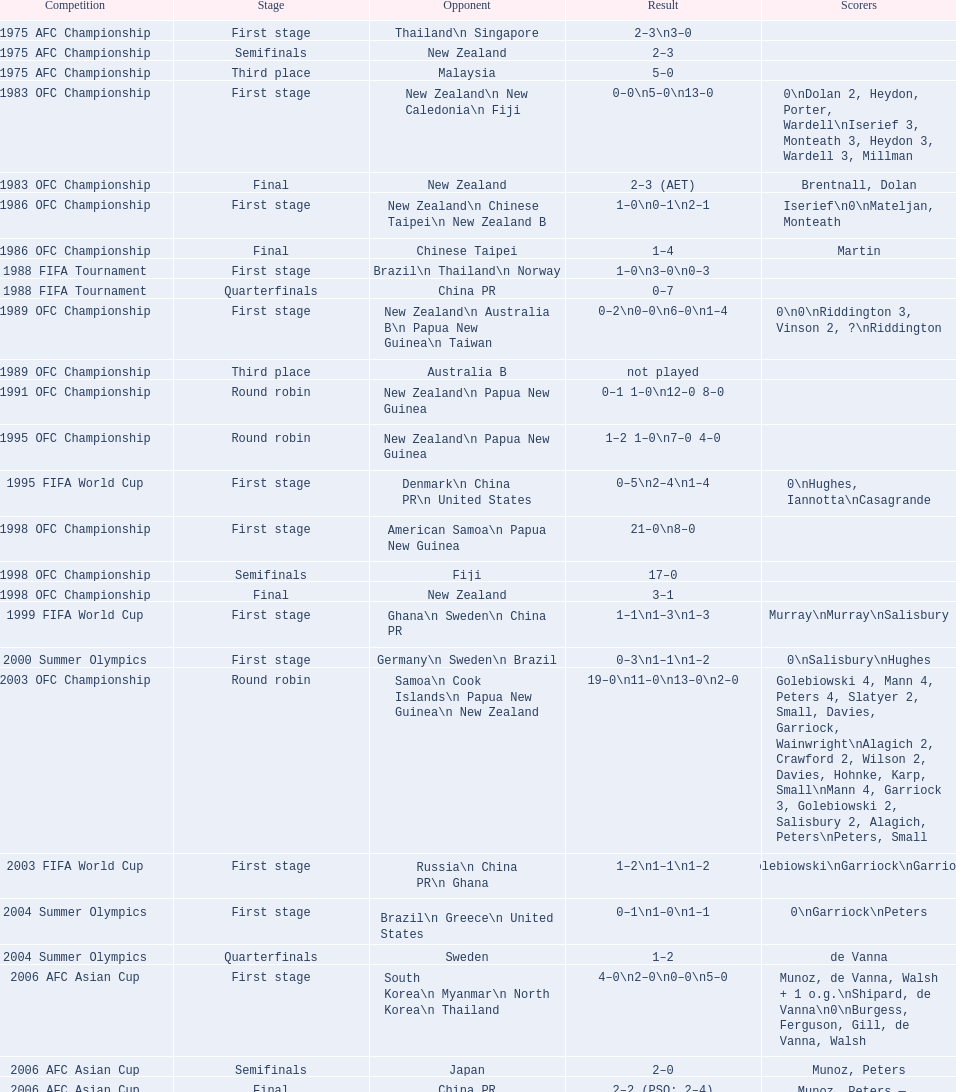Write the full table. {'header': ['Competition', 'Stage', 'Opponent', 'Result', 'Scorers'], 'rows': [['1975 AFC Championship', 'First stage', 'Thailand\\n\xa0Singapore', '2–3\\n3–0', ''], ['1975 AFC Championship', 'Semifinals', 'New Zealand', '2–3', ''], ['1975 AFC Championship', 'Third place', 'Malaysia', '5–0', ''], ['1983 OFC Championship', 'First stage', 'New Zealand\\n\xa0New Caledonia\\n\xa0Fiji', '0–0\\n5–0\\n13–0', '0\\nDolan 2, Heydon, Porter, Wardell\\nIserief 3, Monteath 3, Heydon 3, Wardell 3, Millman'], ['1983 OFC Championship', 'Final', 'New Zealand', '2–3 (AET)', 'Brentnall, Dolan'], ['1986 OFC Championship', 'First stage', 'New Zealand\\n\xa0Chinese Taipei\\n New Zealand B', '1–0\\n0–1\\n2–1', 'Iserief\\n0\\nMateljan, Monteath'], ['1986 OFC Championship', 'Final', 'Chinese Taipei', '1–4', 'Martin'], ['1988 FIFA Tournament', 'First stage', 'Brazil\\n\xa0Thailand\\n\xa0Norway', '1–0\\n3–0\\n0–3', ''], ['1988 FIFA Tournament', 'Quarterfinals', 'China PR', '0–7', ''], ['1989 OFC Championship', 'First stage', 'New Zealand\\n Australia B\\n\xa0Papua New Guinea\\n\xa0Taiwan', '0–2\\n0–0\\n6–0\\n1–4', '0\\n0\\nRiddington 3, Vinson 2,\xa0?\\nRiddington'], ['1989 OFC Championship', 'Third place', 'Australia B', 'not played', ''], ['1991 OFC Championship', 'Round robin', 'New Zealand\\n\xa0Papua New Guinea', '0–1 1–0\\n12–0 8–0', ''], ['1995 OFC Championship', 'Round robin', 'New Zealand\\n\xa0Papua New Guinea', '1–2 1–0\\n7–0 4–0', ''], ['1995 FIFA World Cup', 'First stage', 'Denmark\\n\xa0China PR\\n\xa0United States', '0–5\\n2–4\\n1–4', '0\\nHughes, Iannotta\\nCasagrande'], ['1998 OFC Championship', 'First stage', 'American Samoa\\n\xa0Papua New Guinea', '21–0\\n8–0', ''], ['1998 OFC Championship', 'Semifinals', 'Fiji', '17–0', ''], ['1998 OFC Championship', 'Final', 'New Zealand', '3–1', ''], ['1999 FIFA World Cup', 'First stage', 'Ghana\\n\xa0Sweden\\n\xa0China PR', '1–1\\n1–3\\n1–3', 'Murray\\nMurray\\nSalisbury'], ['2000 Summer Olympics', 'First stage', 'Germany\\n\xa0Sweden\\n\xa0Brazil', '0–3\\n1–1\\n1–2', '0\\nSalisbury\\nHughes'], ['2003 OFC Championship', 'Round robin', 'Samoa\\n\xa0Cook Islands\\n\xa0Papua New Guinea\\n\xa0New Zealand', '19–0\\n11–0\\n13–0\\n2–0', 'Golebiowski 4, Mann 4, Peters 4, Slatyer 2, Small, Davies, Garriock, Wainwright\\nAlagich 2, Crawford 2, Wilson 2, Davies, Hohnke, Karp, Small\\nMann 4, Garriock 3, Golebiowski 2, Salisbury 2, Alagich, Peters\\nPeters, Small'], ['2003 FIFA World Cup', 'First stage', 'Russia\\n\xa0China PR\\n\xa0Ghana', '1–2\\n1–1\\n1–2', 'Golebiowski\\nGarriock\\nGarriock'], ['2004 Summer Olympics', 'First stage', 'Brazil\\n\xa0Greece\\n\xa0United States', '0–1\\n1–0\\n1–1', '0\\nGarriock\\nPeters'], ['2004 Summer Olympics', 'Quarterfinals', 'Sweden', '1–2', 'de Vanna'], ['2006 AFC Asian Cup', 'First stage', 'South Korea\\n\xa0Myanmar\\n\xa0North Korea\\n\xa0Thailand', '4–0\\n2–0\\n0–0\\n5–0', 'Munoz, de Vanna, Walsh + 1 o.g.\\nShipard, de Vanna\\n0\\nBurgess, Ferguson, Gill, de Vanna, Walsh'], ['2006 AFC Asian Cup', 'Semifinals', 'Japan', '2–0', 'Munoz, Peters'], ['2006 AFC Asian Cup', 'Final', 'China PR', '2–2 (PSO: 2–4)', 'Munoz, Peters — Shipard, Ferguson McCallum, Peters'], ['2007 FIFA World Cup', 'First stage', 'Ghana\\n\xa0Norway\\n\xa0Canada', '4–1\\n1–1\\n2–2', 'de Vanna 2, Garriock, Walsh\\nde Vanna\\nMcCallum, Salisbury'], ['2007 FIFA World Cup', 'Quarterfinals', 'Brazil', '2–3', 'Colthorpe, de Vanna'], ['2008 AFC Asian Cup', 'First stage', 'Chinese Taipei\\n\xa0South Korea\\n\xa0Japan', '4–0\\n2–0', 'Garriock 2, Tristram, de Vanna\\nPerry, de Vanna\\nPolkinghorne'], ['2008 AFC Asian Cup', 'Semifinals', 'North Korea', '0–3', ''], ['2008 AFC Asian Cup', 'Third place', 'Japan', '0–3', ''], ['2010 AFC Asian Cup', 'First stage', 'Vietnam\\n\xa0South Korea\\n\xa0China PR', '2–0\\n3–1\\n0–1', 'Khamis, Ledbrook\\nCarroll, Kerr, de Vanna\\n0'], ['2010 AFC Asian Cup', 'Semifinals', 'Japan', '1–0', 'Gill'], ['2010 AFC Asian Cup', 'Final', 'North Korea', '1–1 (PSO: 5–4)', 'Kerr — PSO: Shipard, Ledbrook, Gill, Garriock, Simon'], ['2011 FIFA World Cup', 'First stage', 'Brazil\\n\xa0Equatorial Guinea\\n\xa0Norway', '0–1\\n3–2\\n2–1', '0\\nvan Egmond, Khamis, de Vanna\\nSimon 2'], ['2011 FIFA World Cup', 'Quarterfinals', 'Sweden', '1–3', 'Perry'], ['2012 Summer Olympics\\nAFC qualification', 'Final round', 'North Korea\\n\xa0Thailand\\n\xa0Japan\\n\xa0China PR\\n\xa0South Korea', '0–1\\n5–1\\n0–1\\n1–0\\n2–1', '0\\nHeyman 2, Butt, van Egmond, Simon\\n0\\nvan Egmond\\nButt, de Vanna'], ['2014 AFC Asian Cup', 'First stage', 'Japan\\n\xa0Jordan\\n\xa0Vietnam', 'TBD\\nTBD\\nTBD', '']]} What is the overall count of competitions? 21. 